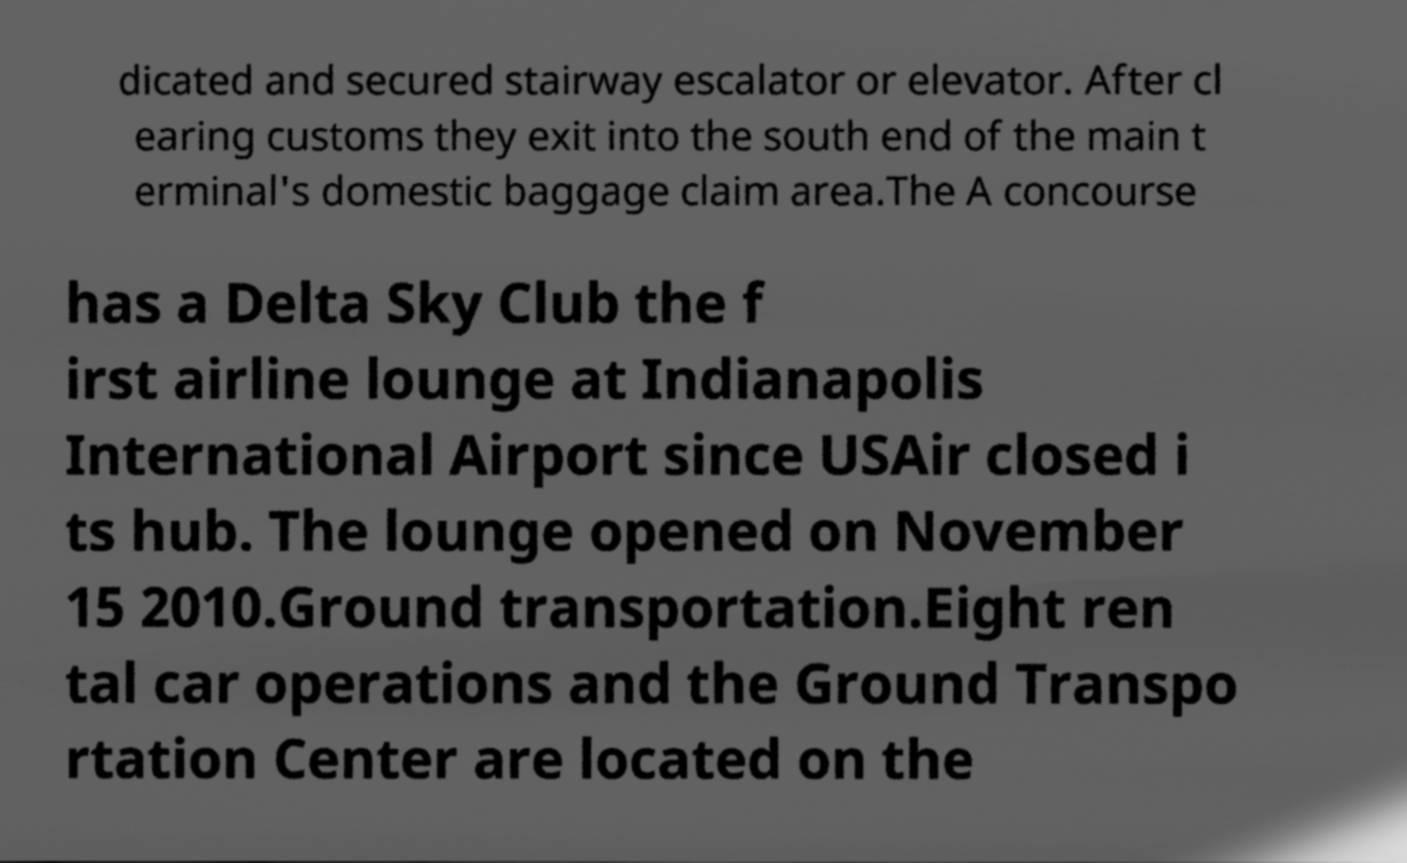Could you assist in decoding the text presented in this image and type it out clearly? dicated and secured stairway escalator or elevator. After cl earing customs they exit into the south end of the main t erminal's domestic baggage claim area.The A concourse has a Delta Sky Club the f irst airline lounge at Indianapolis International Airport since USAir closed i ts hub. The lounge opened on November 15 2010.Ground transportation.Eight ren tal car operations and the Ground Transpo rtation Center are located on the 